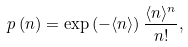Convert formula to latex. <formula><loc_0><loc_0><loc_500><loc_500>p \left ( n \right ) = \exp \left ( - \langle n \rangle \right ) \frac { \langle n \rangle ^ { n } } { n ! } ,</formula> 